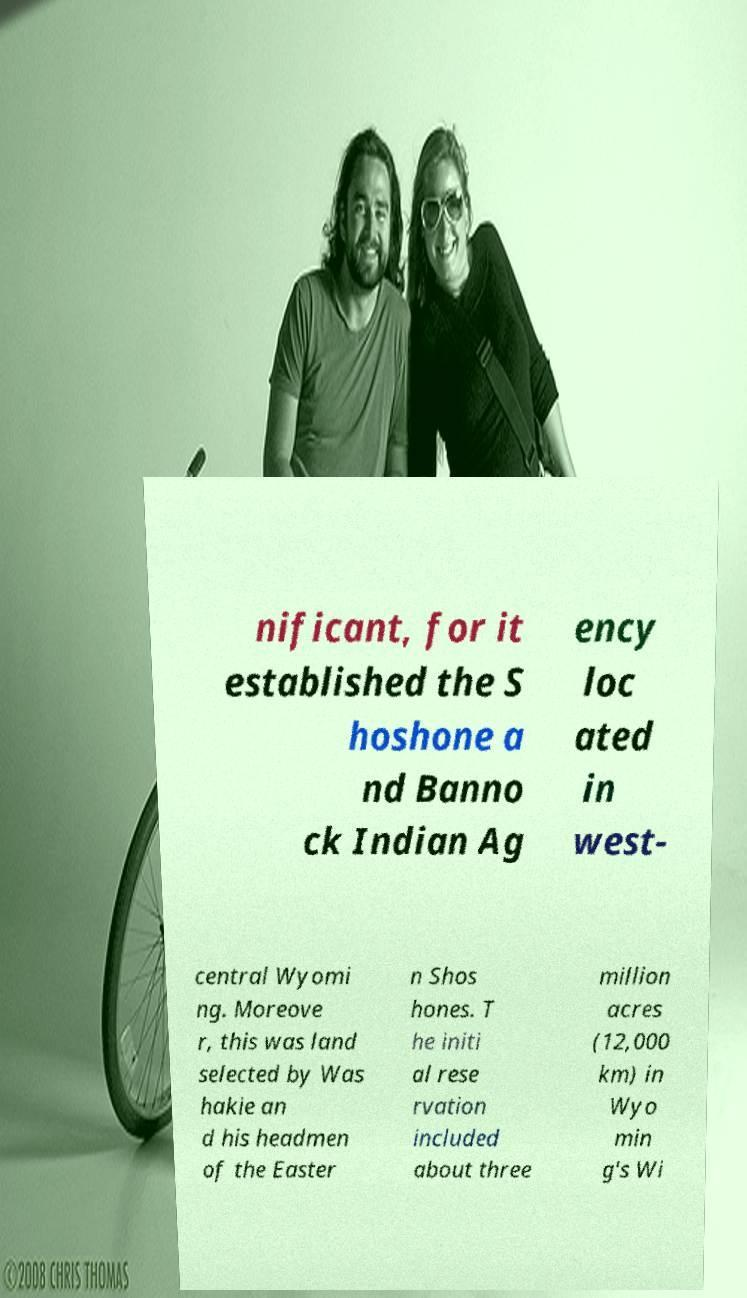There's text embedded in this image that I need extracted. Can you transcribe it verbatim? nificant, for it established the S hoshone a nd Banno ck Indian Ag ency loc ated in west- central Wyomi ng. Moreove r, this was land selected by Was hakie an d his headmen of the Easter n Shos hones. T he initi al rese rvation included about three million acres (12,000 km) in Wyo min g's Wi 